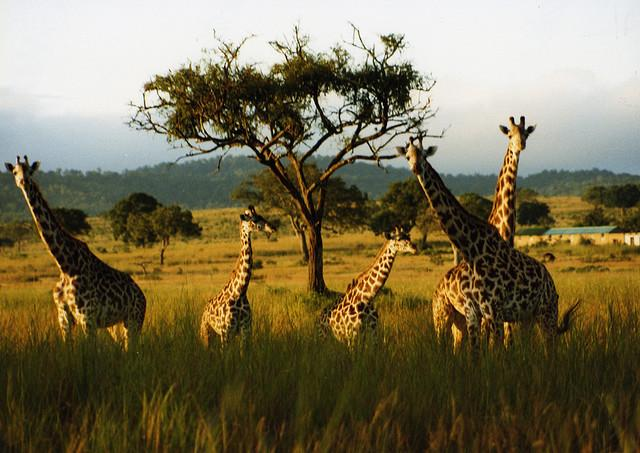How heavy is a newborn giraffe calf in general? quarter ton 